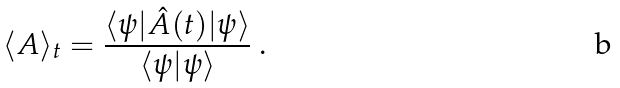Convert formula to latex. <formula><loc_0><loc_0><loc_500><loc_500>\langle A \rangle _ { t } = \frac { \langle \psi | \hat { A } ( t ) | \psi \rangle } { \langle \psi | \psi \rangle } \ .</formula> 